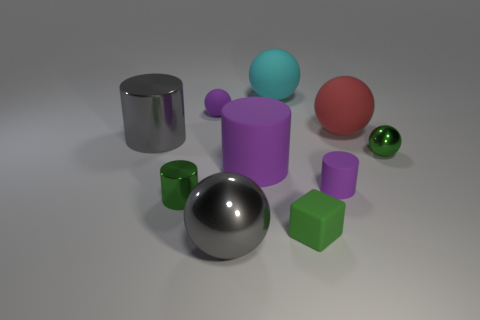Is the green cube made of the same material as the big gray object that is behind the tiny green matte cube?
Give a very brief answer. No. There is a purple matte thing to the right of the small rubber object that is in front of the small rubber cylinder; what number of large red objects are on the left side of it?
Offer a very short reply. 0. Do the red rubber thing and the small purple object that is to the left of the green cube have the same shape?
Keep it short and to the point. Yes. What is the color of the shiny thing that is both on the right side of the small green cylinder and behind the tiny green rubber object?
Make the answer very short. Green. The tiny cylinder left of the small purple matte thing in front of the tiny purple thing that is left of the rubber block is made of what material?
Provide a short and direct response. Metal. What material is the large red thing?
Your answer should be very brief. Rubber. What size is the cyan thing that is the same shape as the red object?
Offer a very short reply. Large. Does the matte cube have the same color as the small matte cylinder?
Ensure brevity in your answer.  No. What number of other objects are there of the same material as the block?
Your answer should be compact. 5. Are there the same number of tiny rubber blocks to the right of the red rubber ball and big purple matte things?
Your response must be concise. No. 